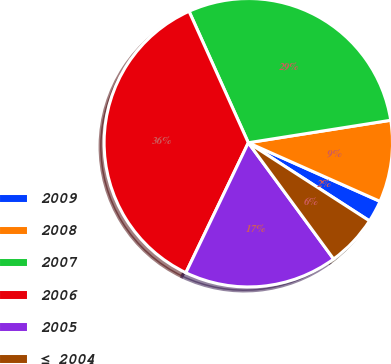Convert chart to OTSL. <chart><loc_0><loc_0><loc_500><loc_500><pie_chart><fcel>2009<fcel>2008<fcel>2007<fcel>2006<fcel>2005<fcel>≤ 2004<nl><fcel>2.45%<fcel>9.16%<fcel>29.25%<fcel>36.13%<fcel>17.2%<fcel>5.81%<nl></chart> 